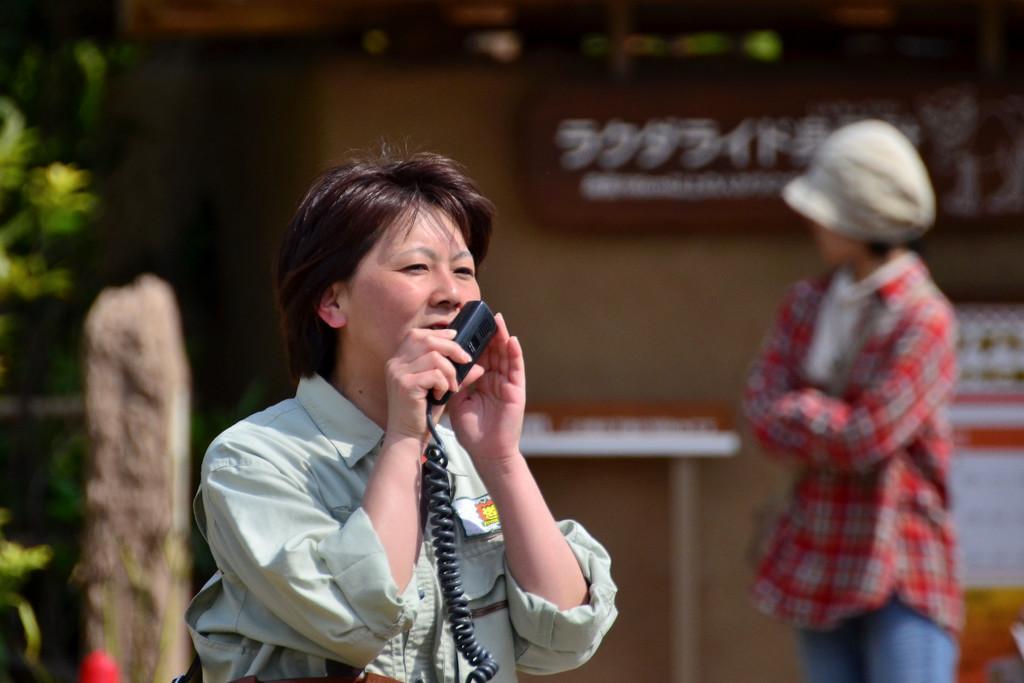Please provide a concise description of this image. In this image we can see a few persons, among them one is holding a phone, in the background there is a board with some text, we can see a rock, table and poster with some text, there are some plants. 